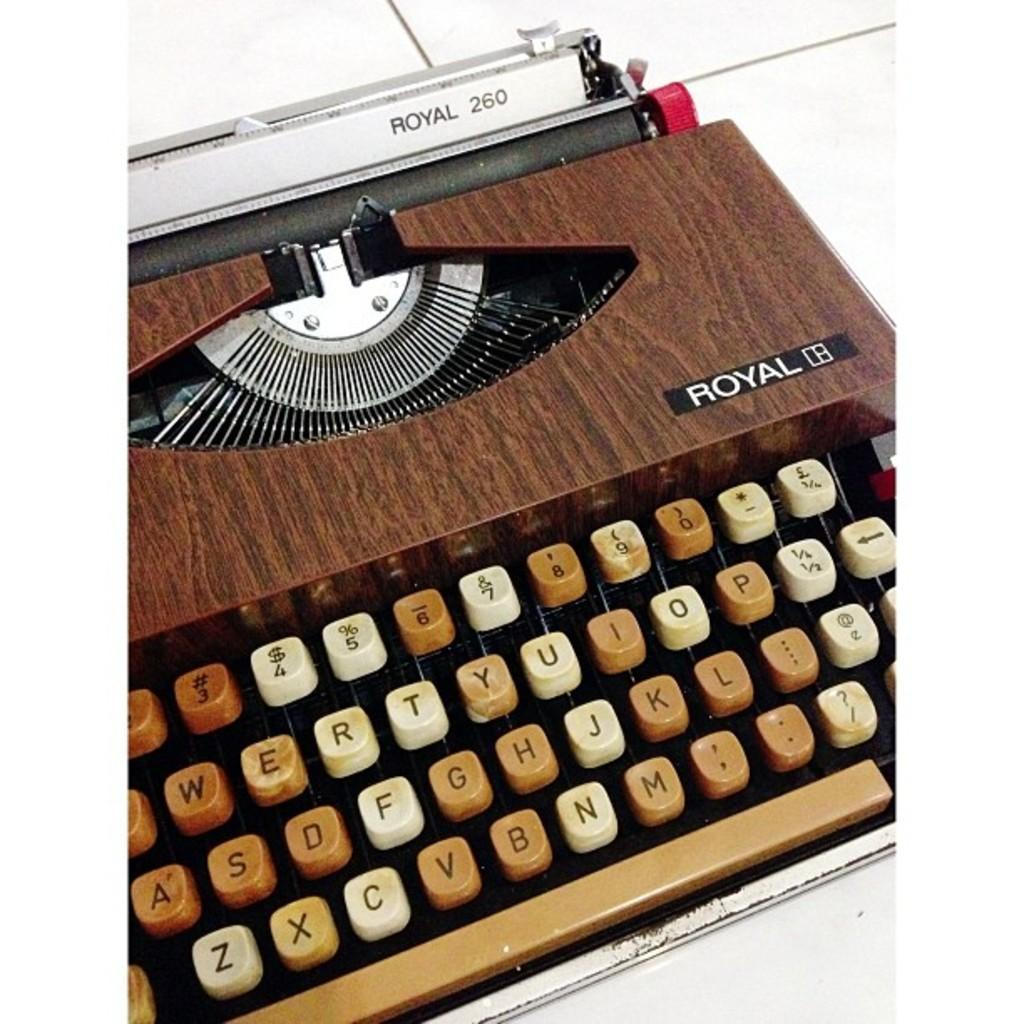<image>
Present a compact description of the photo's key features. A wooden typewriter with the word Royal and the number 260 